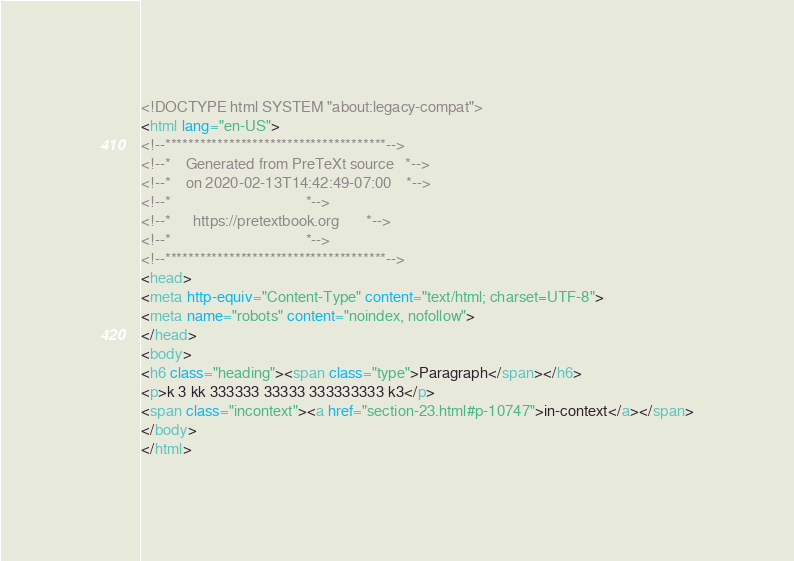<code> <loc_0><loc_0><loc_500><loc_500><_HTML_><!DOCTYPE html SYSTEM "about:legacy-compat">
<html lang="en-US">
<!--**************************************-->
<!--*    Generated from PreTeXt source   *-->
<!--*    on 2020-02-13T14:42:49-07:00    *-->
<!--*                                    *-->
<!--*      https://pretextbook.org       *-->
<!--*                                    *-->
<!--**************************************-->
<head>
<meta http-equiv="Content-Type" content="text/html; charset=UTF-8">
<meta name="robots" content="noindex, nofollow">
</head>
<body>
<h6 class="heading"><span class="type">Paragraph</span></h6>
<p>k 3 kk 333333 33333 333333333 k3</p>
<span class="incontext"><a href="section-23.html#p-10747">in-context</a></span>
</body>
</html>
</code> 